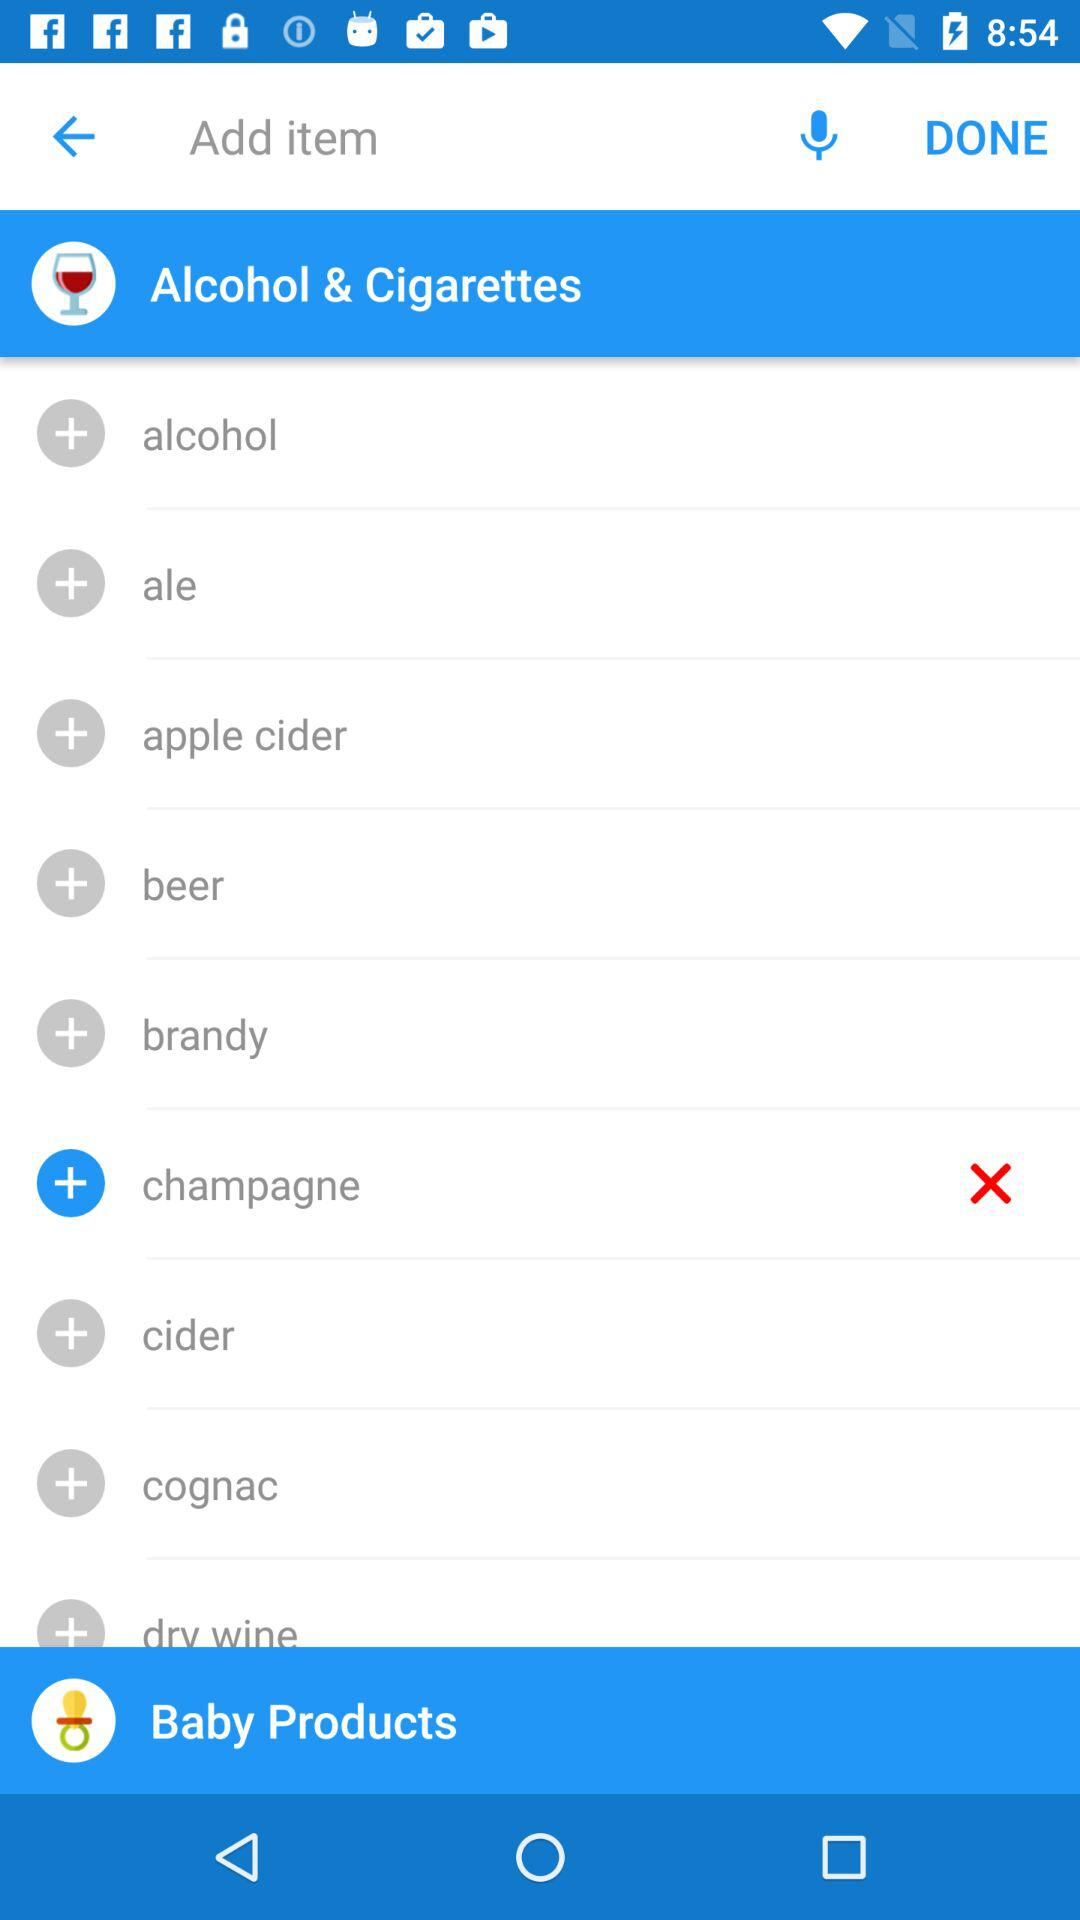Which option has been selected? The option "champagne" has been selected. 